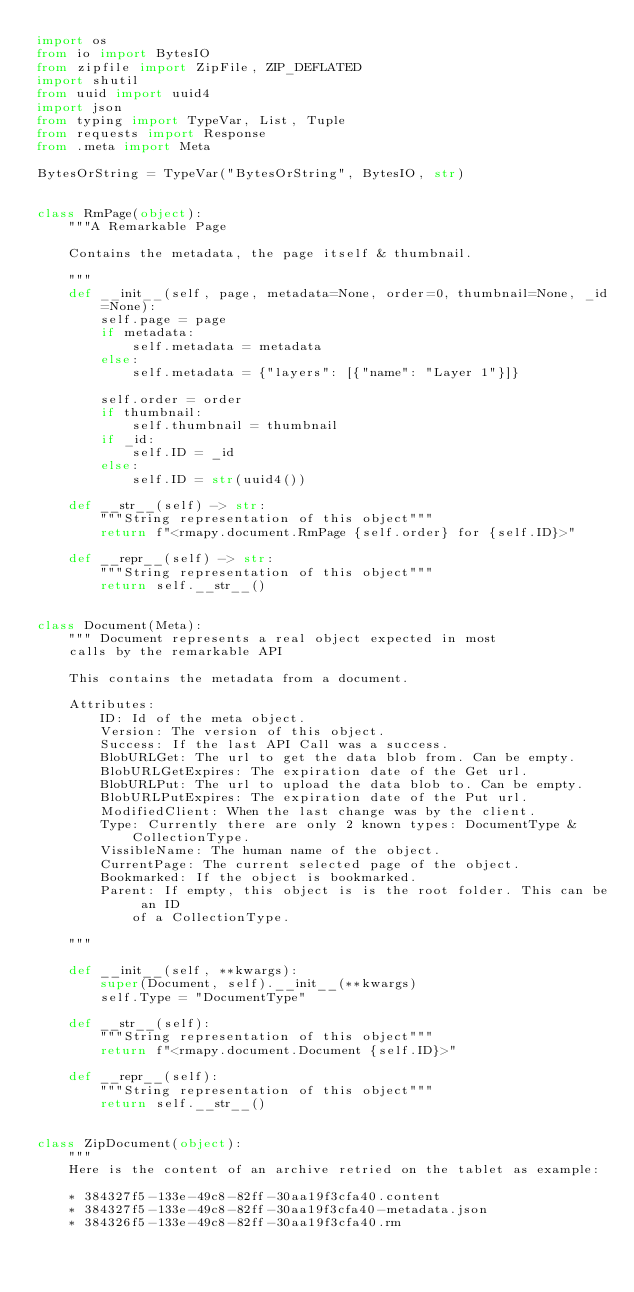Convert code to text. <code><loc_0><loc_0><loc_500><loc_500><_Python_>import os
from io import BytesIO
from zipfile import ZipFile, ZIP_DEFLATED
import shutil
from uuid import uuid4
import json
from typing import TypeVar, List, Tuple
from requests import Response
from .meta import Meta

BytesOrString = TypeVar("BytesOrString", BytesIO, str)


class RmPage(object):
    """A Remarkable Page

    Contains the metadata, the page itself & thumbnail.

    """
    def __init__(self, page, metadata=None, order=0, thumbnail=None, _id=None):
        self.page = page
        if metadata:
            self.metadata = metadata
        else:
            self.metadata = {"layers": [{"name": "Layer 1"}]}

        self.order = order
        if thumbnail:
            self.thumbnail = thumbnail
        if _id:
            self.ID = _id
        else:
            self.ID = str(uuid4())

    def __str__(self) -> str:
        """String representation of this object"""
        return f"<rmapy.document.RmPage {self.order} for {self.ID}>"

    def __repr__(self) -> str:
        """String representation of this object"""
        return self.__str__()


class Document(Meta):
    """ Document represents a real object expected in most
    calls by the remarkable API

    This contains the metadata from a document.

    Attributes:
        ID: Id of the meta object.
        Version: The version of this object.
        Success: If the last API Call was a success.
        BlobURLGet: The url to get the data blob from. Can be empty.
        BlobURLGetExpires: The expiration date of the Get url.
        BlobURLPut: The url to upload the data blob to. Can be empty.
        BlobURLPutExpires: The expiration date of the Put url.
        ModifiedClient: When the last change was by the client.
        Type: Currently there are only 2 known types: DocumentType &
            CollectionType.
        VissibleName: The human name of the object.
        CurrentPage: The current selected page of the object.
        Bookmarked: If the object is bookmarked.
        Parent: If empty, this object is is the root folder. This can be an ID
            of a CollectionType.

    """

    def __init__(self, **kwargs):
        super(Document, self).__init__(**kwargs)
        self.Type = "DocumentType"

    def __str__(self):
        """String representation of this object"""
        return f"<rmapy.document.Document {self.ID}>"

    def __repr__(self):
        """String representation of this object"""
        return self.__str__()


class ZipDocument(object):
    """
    Here is the content of an archive retried on the tablet as example:

    * 384327f5-133e-49c8-82ff-30aa19f3cfa40.content
    * 384327f5-133e-49c8-82ff-30aa19f3cfa40-metadata.json
    * 384326f5-133e-49c8-82ff-30aa19f3cfa40.rm</code> 